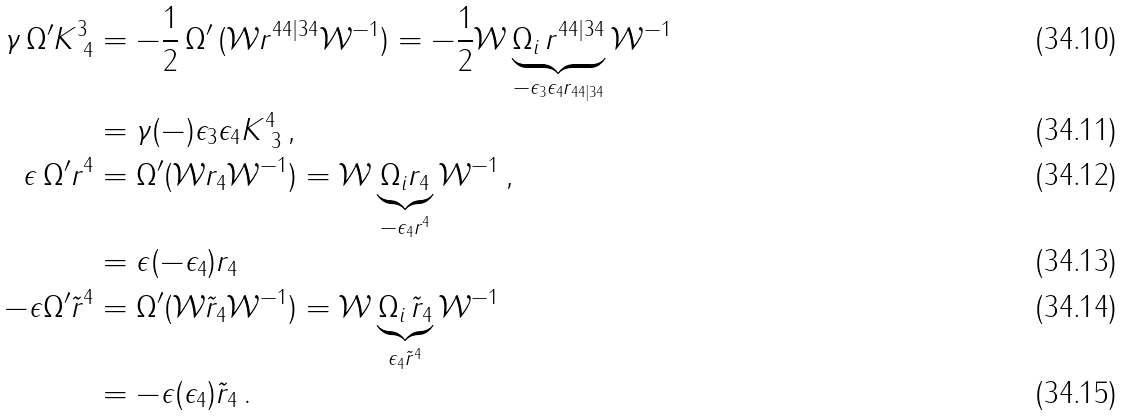<formula> <loc_0><loc_0><loc_500><loc_500>\gamma \, \Omega ^ { \prime } K ^ { 3 } _ { \ 4 } & = - \frac { 1 } { 2 } \, \Omega ^ { \prime } \, ( \mathcal { W } r ^ { 4 4 | 3 4 } \mathcal { W } ^ { - 1 } ) = - \frac { 1 } { 2 } \mathcal { W } \underbrace { \Omega _ { i } \, r ^ { 4 4 | 3 4 } } _ { - \epsilon _ { 3 } \epsilon _ { 4 } r _ { 4 4 | 3 4 } } \mathcal { W } ^ { - 1 } \\ & = \gamma ( - ) \epsilon _ { 3 } \epsilon _ { 4 } K ^ { 4 } _ { \ 3 } \, , \\ \epsilon \, \Omega ^ { \prime } r ^ { 4 } & = \Omega ^ { \prime } ( \mathcal { W } r _ { 4 } \mathcal { W } ^ { - 1 } ) = \mathcal { W } \underbrace { \Omega _ { i } r _ { 4 } } _ { - \epsilon _ { 4 } r ^ { 4 } } \mathcal { W } ^ { - 1 } \, , \\ & = \epsilon ( - \epsilon _ { 4 } ) r _ { 4 } \\ - \epsilon \Omega ^ { \prime } \tilde { r } ^ { 4 } & = \Omega ^ { \prime } ( \mathcal { W } \tilde { r } _ { 4 } \mathcal { W } ^ { - 1 } ) = \mathcal { W } \underbrace { \Omega _ { i } \, \tilde { r } _ { 4 } } _ { \epsilon _ { 4 } \tilde { r } ^ { 4 } } \mathcal { W } ^ { - 1 } \\ & = - \epsilon ( \epsilon _ { 4 } ) \tilde { r } _ { 4 } \, .</formula> 